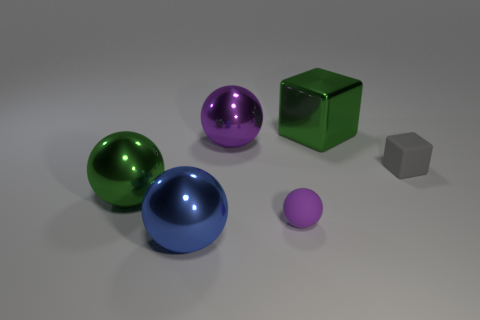The block that is made of the same material as the small purple sphere is what color?
Provide a short and direct response. Gray. There is a thing that is the same color as the small ball; what is its shape?
Your answer should be compact. Sphere. There is a blue metallic thing that is on the left side of the gray matte cube; does it have the same size as the purple sphere in front of the gray matte cube?
Ensure brevity in your answer.  No. What number of cubes are blue objects or small gray things?
Ensure brevity in your answer.  1. Are the large object that is on the left side of the large blue object and the gray object made of the same material?
Offer a terse response. No. What number of other things are the same size as the blue sphere?
Your response must be concise. 3. What number of tiny things are rubber cylinders or cubes?
Give a very brief answer. 1. Do the metallic block and the tiny matte cube have the same color?
Make the answer very short. No. Is the number of green metal blocks that are in front of the big purple metallic sphere greater than the number of blue metallic spheres on the right side of the blue metallic object?
Your response must be concise. No. There is a big sphere that is behind the green shiny sphere; is it the same color as the big metal block?
Offer a terse response. No. 